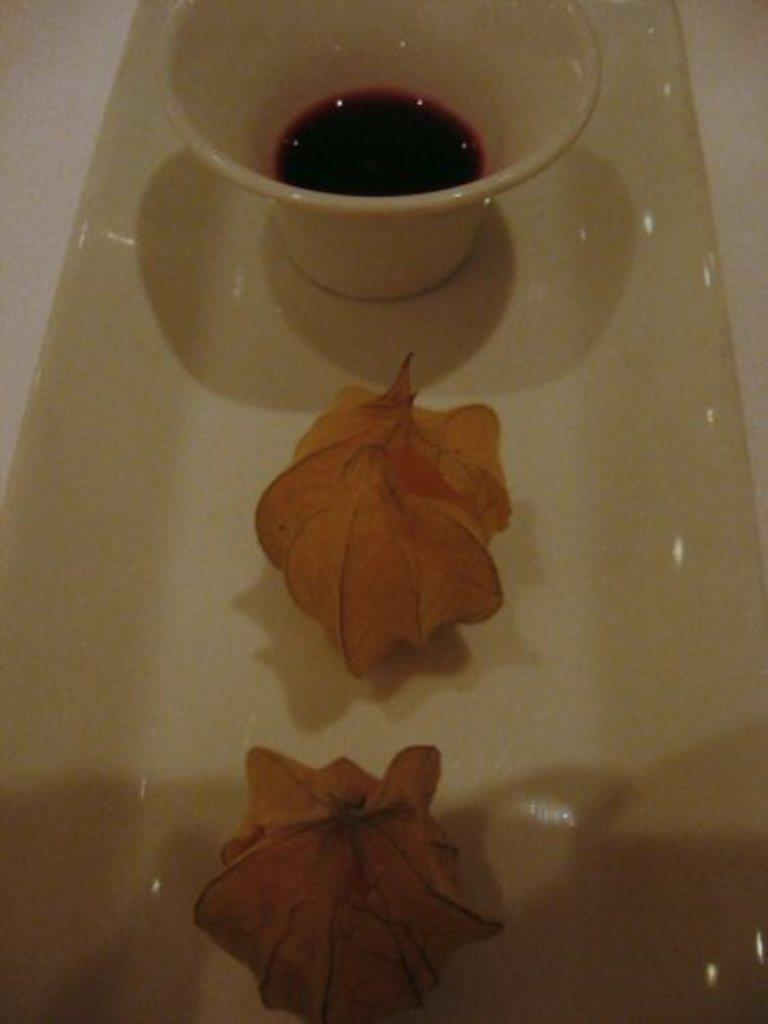Where was the image taken? The image is taken indoors. What is the main object in the middle of the image? There is a tray in the middle of the image. What is on the tray? The tray contains a food item and a bowl with sauce. On what surface is the tray placed? The tray is placed on a table. Can you see an owl sitting on the food item in the image? No, there is no owl present in the image. How many times does the food item turn on the tray during the course of the image? The food item does not turn on the tray in the image; it remains stationary. 